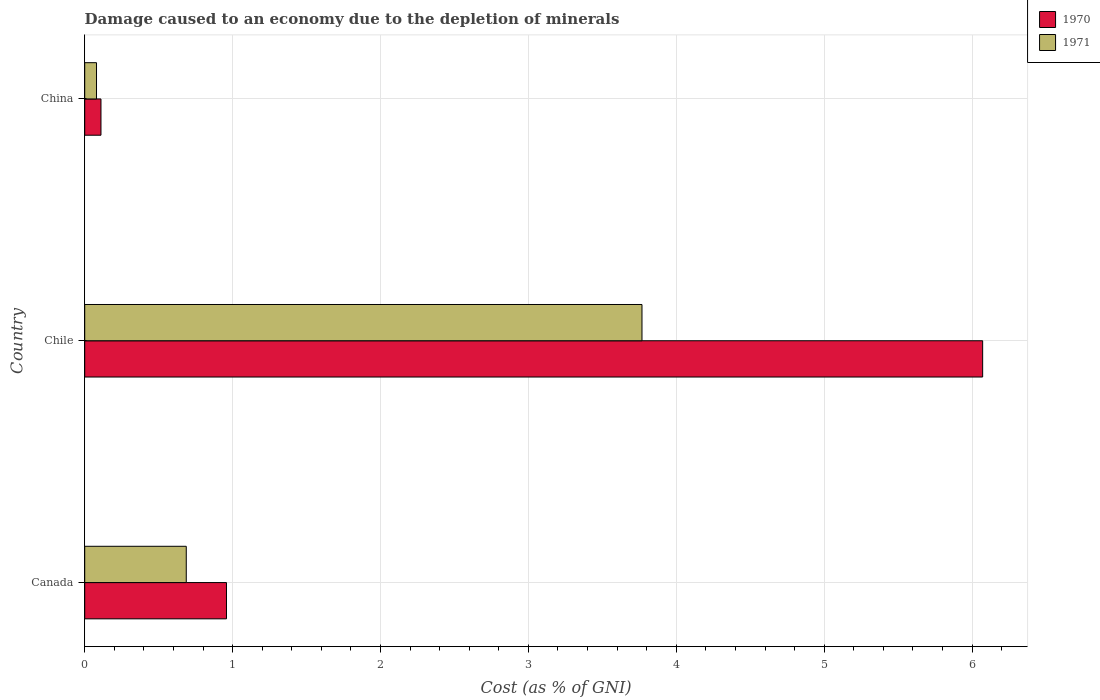How many different coloured bars are there?
Provide a short and direct response. 2. How many groups of bars are there?
Your answer should be very brief. 3. Are the number of bars per tick equal to the number of legend labels?
Offer a terse response. Yes. Are the number of bars on each tick of the Y-axis equal?
Give a very brief answer. Yes. How many bars are there on the 3rd tick from the bottom?
Provide a succinct answer. 2. In how many cases, is the number of bars for a given country not equal to the number of legend labels?
Provide a succinct answer. 0. What is the cost of damage caused due to the depletion of minerals in 1971 in Chile?
Your answer should be compact. 3.77. Across all countries, what is the maximum cost of damage caused due to the depletion of minerals in 1970?
Give a very brief answer. 6.07. Across all countries, what is the minimum cost of damage caused due to the depletion of minerals in 1971?
Ensure brevity in your answer.  0.08. In which country was the cost of damage caused due to the depletion of minerals in 1970 maximum?
Your response must be concise. Chile. What is the total cost of damage caused due to the depletion of minerals in 1971 in the graph?
Provide a short and direct response. 4.53. What is the difference between the cost of damage caused due to the depletion of minerals in 1971 in Chile and that in China?
Your answer should be compact. 3.69. What is the difference between the cost of damage caused due to the depletion of minerals in 1971 in Chile and the cost of damage caused due to the depletion of minerals in 1970 in Canada?
Provide a short and direct response. 2.81. What is the average cost of damage caused due to the depletion of minerals in 1970 per country?
Offer a terse response. 2.38. What is the difference between the cost of damage caused due to the depletion of minerals in 1970 and cost of damage caused due to the depletion of minerals in 1971 in Chile?
Ensure brevity in your answer.  2.3. In how many countries, is the cost of damage caused due to the depletion of minerals in 1971 greater than 2.4 %?
Offer a very short reply. 1. What is the ratio of the cost of damage caused due to the depletion of minerals in 1971 in Canada to that in Chile?
Your answer should be compact. 0.18. Is the cost of damage caused due to the depletion of minerals in 1970 in Canada less than that in China?
Keep it short and to the point. No. Is the difference between the cost of damage caused due to the depletion of minerals in 1970 in Canada and Chile greater than the difference between the cost of damage caused due to the depletion of minerals in 1971 in Canada and Chile?
Your answer should be very brief. No. What is the difference between the highest and the second highest cost of damage caused due to the depletion of minerals in 1971?
Offer a very short reply. 3.08. What is the difference between the highest and the lowest cost of damage caused due to the depletion of minerals in 1971?
Offer a terse response. 3.69. In how many countries, is the cost of damage caused due to the depletion of minerals in 1970 greater than the average cost of damage caused due to the depletion of minerals in 1970 taken over all countries?
Your answer should be very brief. 1. Is the sum of the cost of damage caused due to the depletion of minerals in 1971 in Chile and China greater than the maximum cost of damage caused due to the depletion of minerals in 1970 across all countries?
Your answer should be compact. No. How many bars are there?
Offer a very short reply. 6. How many countries are there in the graph?
Make the answer very short. 3. What is the difference between two consecutive major ticks on the X-axis?
Offer a terse response. 1. Are the values on the major ticks of X-axis written in scientific E-notation?
Your response must be concise. No. How many legend labels are there?
Offer a terse response. 2. What is the title of the graph?
Ensure brevity in your answer.  Damage caused to an economy due to the depletion of minerals. Does "2015" appear as one of the legend labels in the graph?
Your answer should be very brief. No. What is the label or title of the X-axis?
Give a very brief answer. Cost (as % of GNI). What is the label or title of the Y-axis?
Your answer should be very brief. Country. What is the Cost (as % of GNI) of 1970 in Canada?
Provide a succinct answer. 0.96. What is the Cost (as % of GNI) of 1971 in Canada?
Give a very brief answer. 0.69. What is the Cost (as % of GNI) of 1970 in Chile?
Keep it short and to the point. 6.07. What is the Cost (as % of GNI) of 1971 in Chile?
Make the answer very short. 3.77. What is the Cost (as % of GNI) of 1970 in China?
Your answer should be very brief. 0.11. What is the Cost (as % of GNI) of 1971 in China?
Keep it short and to the point. 0.08. Across all countries, what is the maximum Cost (as % of GNI) of 1970?
Provide a succinct answer. 6.07. Across all countries, what is the maximum Cost (as % of GNI) in 1971?
Provide a short and direct response. 3.77. Across all countries, what is the minimum Cost (as % of GNI) in 1970?
Provide a succinct answer. 0.11. Across all countries, what is the minimum Cost (as % of GNI) in 1971?
Keep it short and to the point. 0.08. What is the total Cost (as % of GNI) of 1970 in the graph?
Your answer should be compact. 7.14. What is the total Cost (as % of GNI) in 1971 in the graph?
Your answer should be compact. 4.53. What is the difference between the Cost (as % of GNI) in 1970 in Canada and that in Chile?
Provide a short and direct response. -5.11. What is the difference between the Cost (as % of GNI) of 1971 in Canada and that in Chile?
Give a very brief answer. -3.08. What is the difference between the Cost (as % of GNI) of 1970 in Canada and that in China?
Your answer should be very brief. 0.85. What is the difference between the Cost (as % of GNI) in 1971 in Canada and that in China?
Your response must be concise. 0.61. What is the difference between the Cost (as % of GNI) in 1970 in Chile and that in China?
Keep it short and to the point. 5.96. What is the difference between the Cost (as % of GNI) in 1971 in Chile and that in China?
Your response must be concise. 3.69. What is the difference between the Cost (as % of GNI) in 1970 in Canada and the Cost (as % of GNI) in 1971 in Chile?
Keep it short and to the point. -2.81. What is the difference between the Cost (as % of GNI) in 1970 in Canada and the Cost (as % of GNI) in 1971 in China?
Your response must be concise. 0.88. What is the difference between the Cost (as % of GNI) in 1970 in Chile and the Cost (as % of GNI) in 1971 in China?
Offer a terse response. 5.99. What is the average Cost (as % of GNI) in 1970 per country?
Your response must be concise. 2.38. What is the average Cost (as % of GNI) in 1971 per country?
Offer a terse response. 1.51. What is the difference between the Cost (as % of GNI) in 1970 and Cost (as % of GNI) in 1971 in Canada?
Keep it short and to the point. 0.27. What is the difference between the Cost (as % of GNI) of 1970 and Cost (as % of GNI) of 1971 in Chile?
Your answer should be very brief. 2.3. What is the difference between the Cost (as % of GNI) in 1970 and Cost (as % of GNI) in 1971 in China?
Make the answer very short. 0.03. What is the ratio of the Cost (as % of GNI) of 1970 in Canada to that in Chile?
Make the answer very short. 0.16. What is the ratio of the Cost (as % of GNI) in 1971 in Canada to that in Chile?
Give a very brief answer. 0.18. What is the ratio of the Cost (as % of GNI) of 1970 in Canada to that in China?
Your answer should be compact. 8.72. What is the ratio of the Cost (as % of GNI) in 1971 in Canada to that in China?
Offer a very short reply. 8.61. What is the ratio of the Cost (as % of GNI) in 1970 in Chile to that in China?
Offer a terse response. 55.21. What is the ratio of the Cost (as % of GNI) of 1971 in Chile to that in China?
Provide a short and direct response. 47.22. What is the difference between the highest and the second highest Cost (as % of GNI) of 1970?
Keep it short and to the point. 5.11. What is the difference between the highest and the second highest Cost (as % of GNI) in 1971?
Give a very brief answer. 3.08. What is the difference between the highest and the lowest Cost (as % of GNI) in 1970?
Ensure brevity in your answer.  5.96. What is the difference between the highest and the lowest Cost (as % of GNI) in 1971?
Offer a terse response. 3.69. 